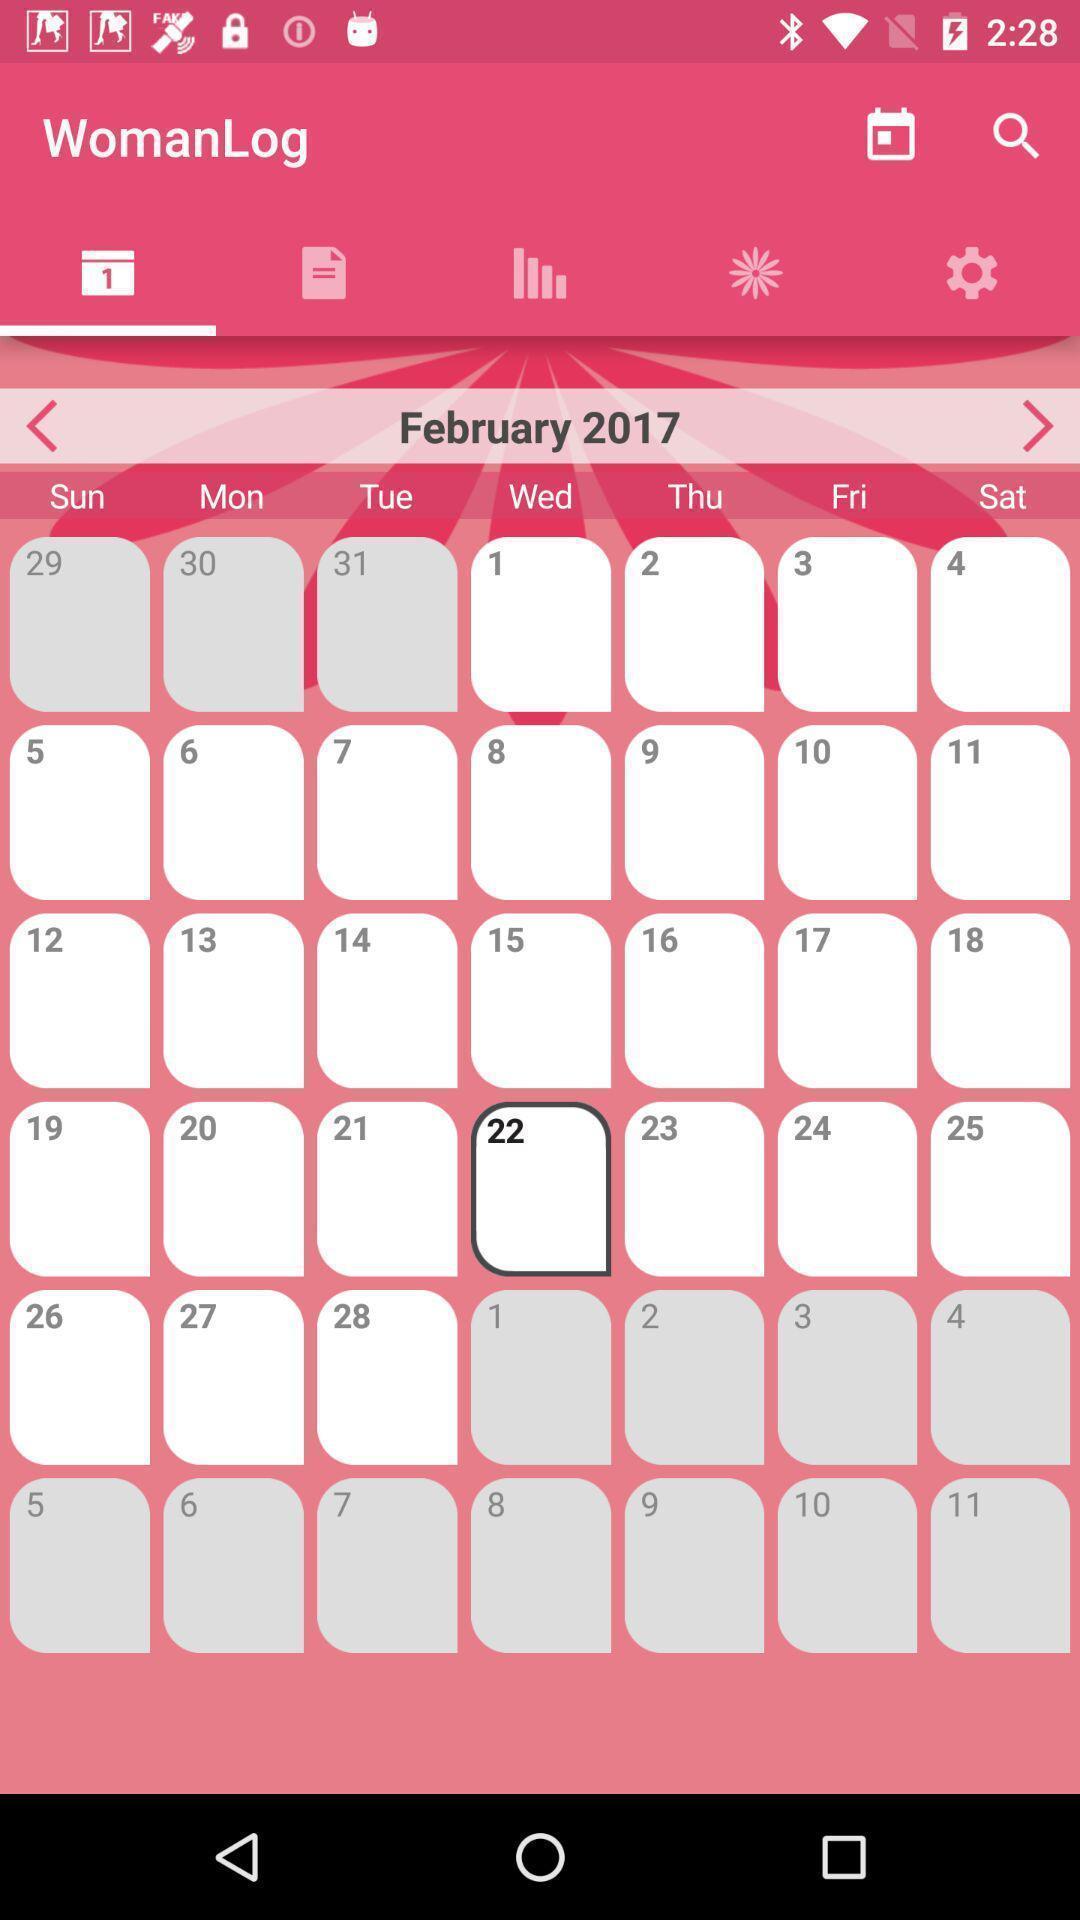Give me a summary of this screen capture. Screen shows womanlog of calender. 